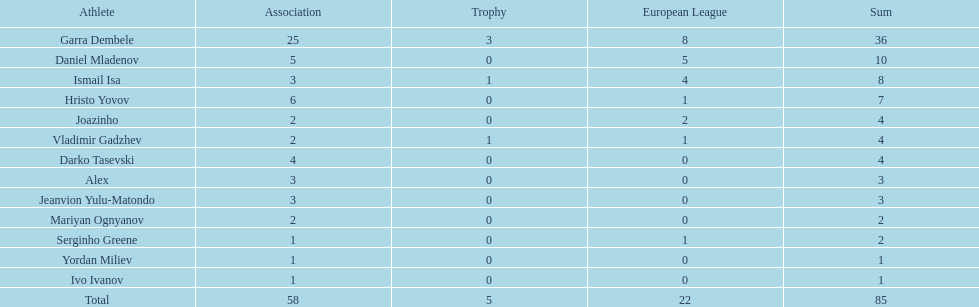What is the sum of the cup total and the europa league total? 27. 